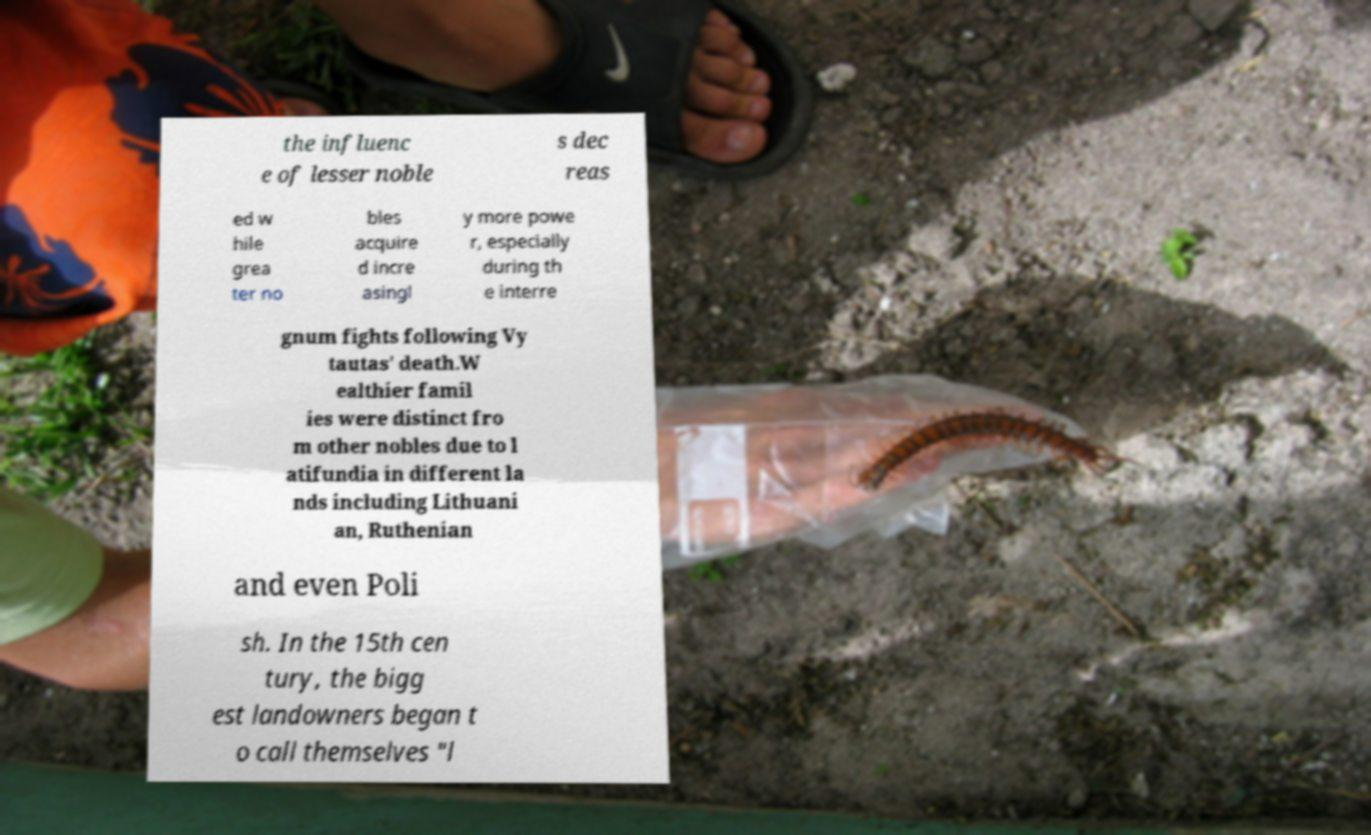Please read and relay the text visible in this image. What does it say? the influenc e of lesser noble s dec reas ed w hile grea ter no bles acquire d incre asingl y more powe r, especially during th e interre gnum fights following Vy tautas' death.W ealthier famil ies were distinct fro m other nobles due to l atifundia in different la nds including Lithuani an, Ruthenian and even Poli sh. In the 15th cen tury, the bigg est landowners began t o call themselves "l 